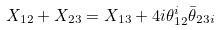Convert formula to latex. <formula><loc_0><loc_0><loc_500><loc_500>X _ { 1 2 } + X _ { 2 3 } = X _ { 1 3 } + 4 i \theta _ { 1 2 } ^ { i } \bar { \theta } _ { 2 3 i }</formula> 